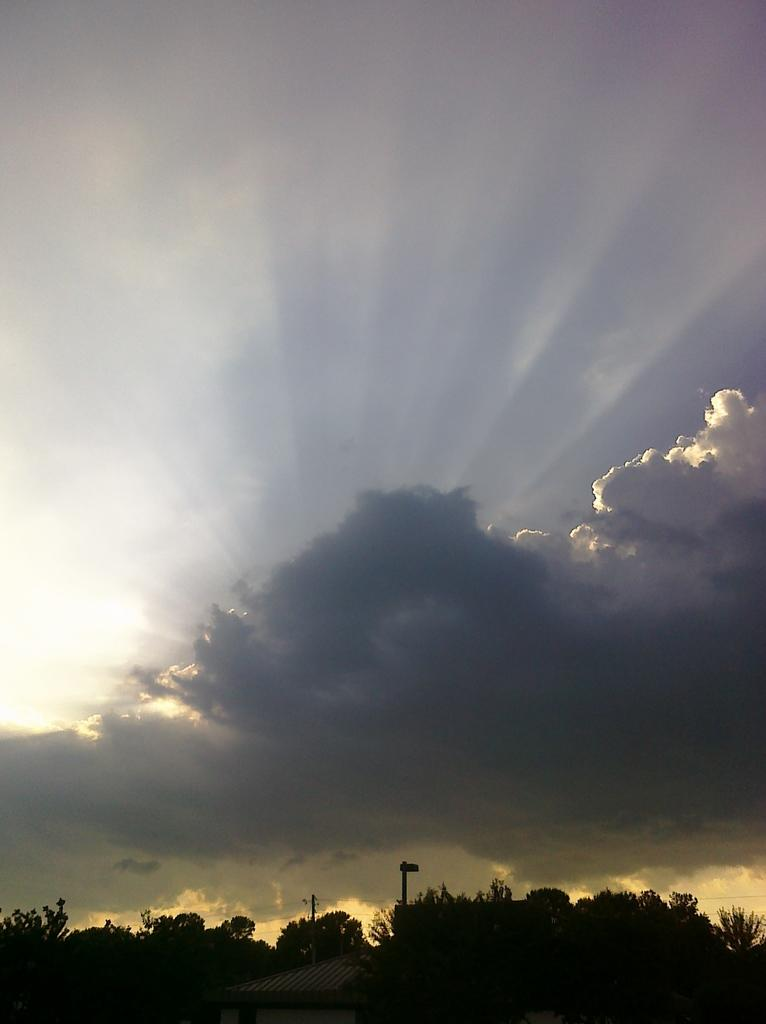What type of view is shown in the image? The image is an outside view. What structures are located at the bottom of the image? There is a house and trees at the bottom of the image. What is visible at the top of the image? The sky is visible at the top of the image. What can be seen in the sky in the image? Clouds are present in the sky. What mathematical operation is being performed by the tree in the image? There is no mathematical operation being performed by the tree in the image, as trees are not capable of performing such actions. 